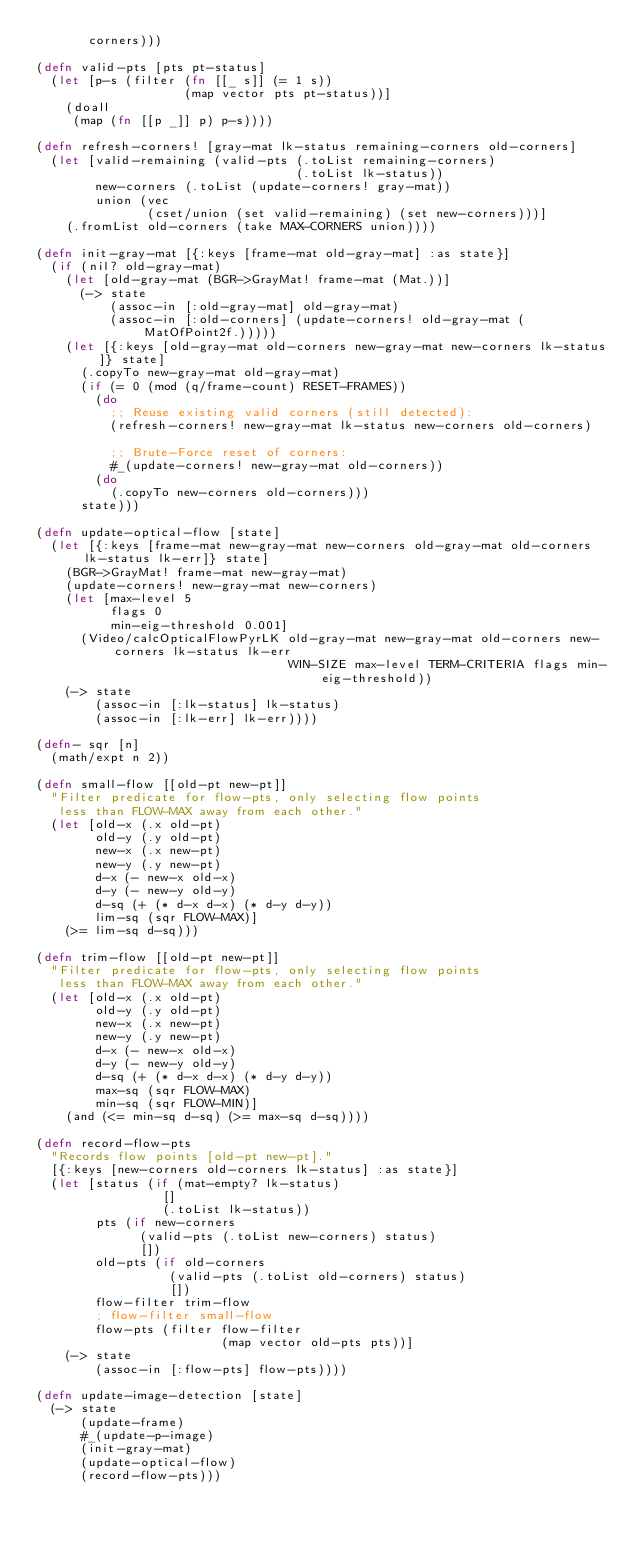Convert code to text. <code><loc_0><loc_0><loc_500><loc_500><_Clojure_>       corners)))

(defn valid-pts [pts pt-status]
  (let [p-s (filter (fn [[_ s]] (= 1 s))
                    (map vector pts pt-status))]
    (doall
     (map (fn [[p _]] p) p-s))))

(defn refresh-corners! [gray-mat lk-status remaining-corners old-corners]
  (let [valid-remaining (valid-pts (.toList remaining-corners)
                                   (.toList lk-status))
        new-corners (.toList (update-corners! gray-mat))
        union (vec
               (cset/union (set valid-remaining) (set new-corners)))]
    (.fromList old-corners (take MAX-CORNERS union))))

(defn init-gray-mat [{:keys [frame-mat old-gray-mat] :as state}]
  (if (nil? old-gray-mat)
    (let [old-gray-mat (BGR->GrayMat! frame-mat (Mat.))]
      (-> state
          (assoc-in [:old-gray-mat] old-gray-mat)
          (assoc-in [:old-corners] (update-corners! old-gray-mat (MatOfPoint2f.)))))
    (let [{:keys [old-gray-mat old-corners new-gray-mat new-corners lk-status]} state]
      (.copyTo new-gray-mat old-gray-mat)
      (if (= 0 (mod (q/frame-count) RESET-FRAMES))
        (do
          ;; Reuse existing valid corners (still detected):
          (refresh-corners! new-gray-mat lk-status new-corners old-corners)

          ;; Brute-Force reset of corners:
          #_(update-corners! new-gray-mat old-corners))
        (do
          (.copyTo new-corners old-corners)))
      state))) 

(defn update-optical-flow [state]
  (let [{:keys [frame-mat new-gray-mat new-corners old-gray-mat old-corners lk-status lk-err]} state]
    (BGR->GrayMat! frame-mat new-gray-mat)
    (update-corners! new-gray-mat new-corners)
    (let [max-level 5
          flags 0
          min-eig-threshold 0.001]
      (Video/calcOpticalFlowPyrLK old-gray-mat new-gray-mat old-corners new-corners lk-status lk-err
                                  WIN-SIZE max-level TERM-CRITERIA flags min-eig-threshold))
    (-> state
        (assoc-in [:lk-status] lk-status)
        (assoc-in [:lk-err] lk-err))))

(defn- sqr [n]
  (math/expt n 2))

(defn small-flow [[old-pt new-pt]]
  "Filter predicate for flow-pts, only selecting flow points
   less than FLOW-MAX away from each other."
  (let [old-x (.x old-pt)
        old-y (.y old-pt)
        new-x (.x new-pt)
        new-y (.y new-pt)
        d-x (- new-x old-x)
        d-y (- new-y old-y)
        d-sq (+ (* d-x d-x) (* d-y d-y))
        lim-sq (sqr FLOW-MAX)]
    (>= lim-sq d-sq)))

(defn trim-flow [[old-pt new-pt]]
  "Filter predicate for flow-pts, only selecting flow points
   less than FLOW-MAX away from each other."
  (let [old-x (.x old-pt)
        old-y (.y old-pt)
        new-x (.x new-pt)
        new-y (.y new-pt)
        d-x (- new-x old-x)
        d-y (- new-y old-y)
        d-sq (+ (* d-x d-x) (* d-y d-y))
        max-sq (sqr FLOW-MAX)
        min-sq (sqr FLOW-MIN)]
    (and (<= min-sq d-sq) (>= max-sq d-sq))))

(defn record-flow-pts
  "Records flow points [old-pt new-pt]."
  [{:keys [new-corners old-corners lk-status] :as state}]
  (let [status (if (mat-empty? lk-status)
                 []
                 (.toList lk-status))
        pts (if new-corners
              (valid-pts (.toList new-corners) status)
              [])
        old-pts (if old-corners
                  (valid-pts (.toList old-corners) status)
                  [])
        flow-filter trim-flow
        ; flow-filter small-flow
        flow-pts (filter flow-filter
                         (map vector old-pts pts))]
    (-> state
        (assoc-in [:flow-pts] flow-pts))))

(defn update-image-detection [state]
  (-> state
      (update-frame)
      #_(update-p-image)
      (init-gray-mat)
      (update-optical-flow)
      (record-flow-pts)))
</code> 